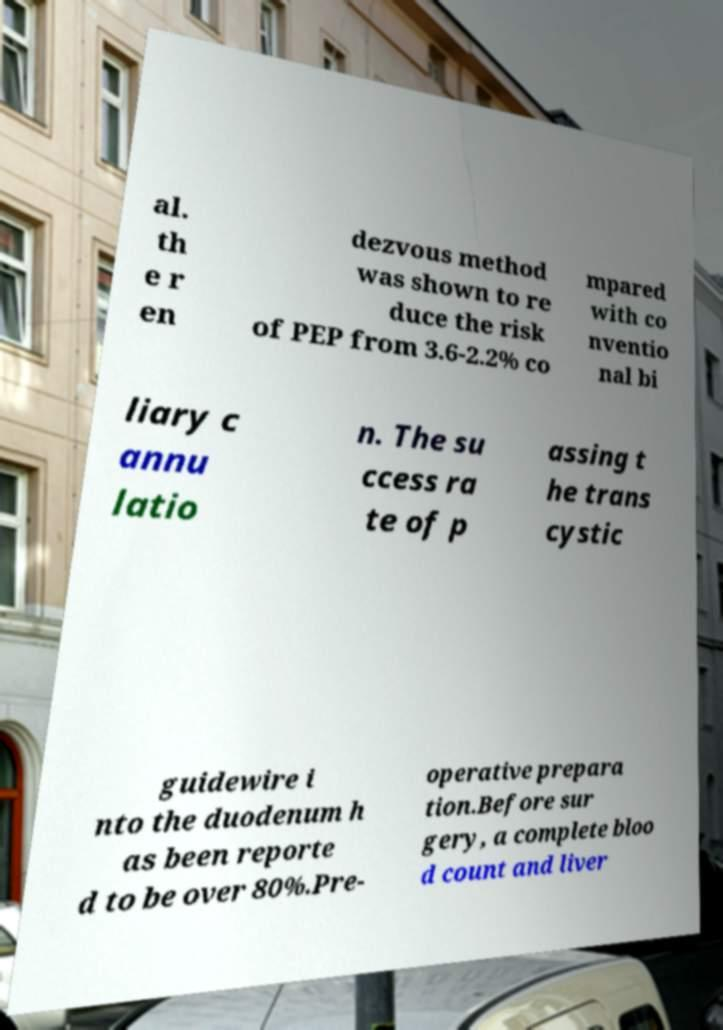What messages or text are displayed in this image? I need them in a readable, typed format. al. th e r en dezvous method was shown to re duce the risk of PEP from 3.6-2.2% co mpared with co nventio nal bi liary c annu latio n. The su ccess ra te of p assing t he trans cystic guidewire i nto the duodenum h as been reporte d to be over 80%.Pre- operative prepara tion.Before sur gery, a complete bloo d count and liver 